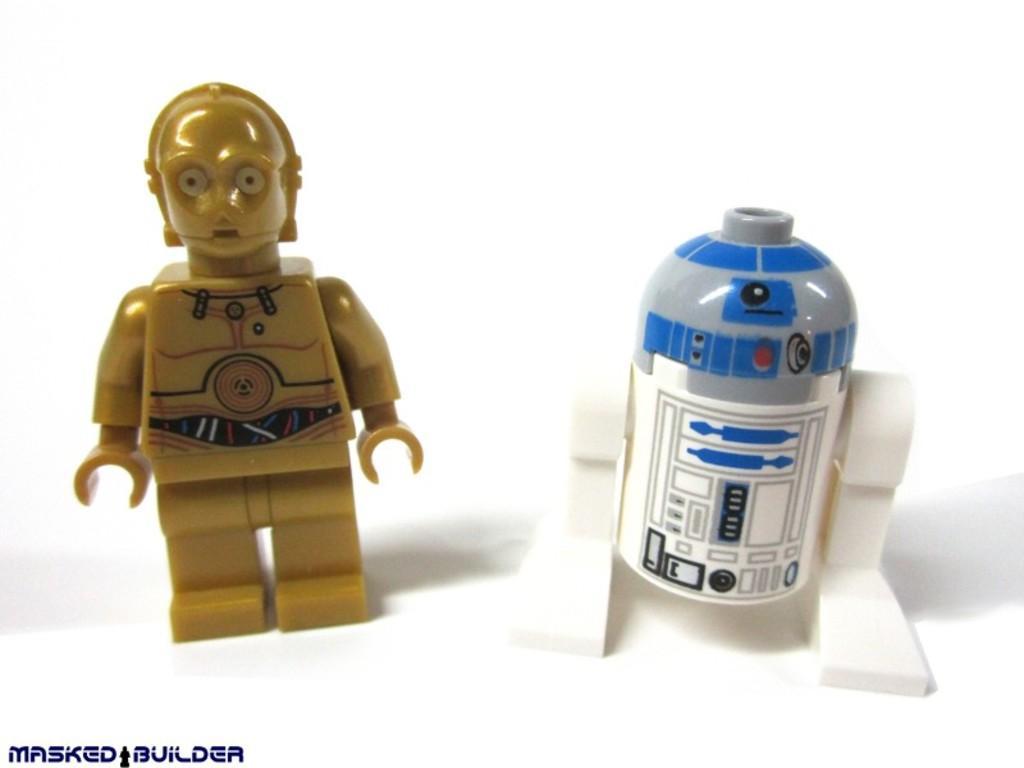Describe this image in one or two sentences. In this picture there is a toy, beside that I can see the bottle. In the bottom left corner there is a watermark. 